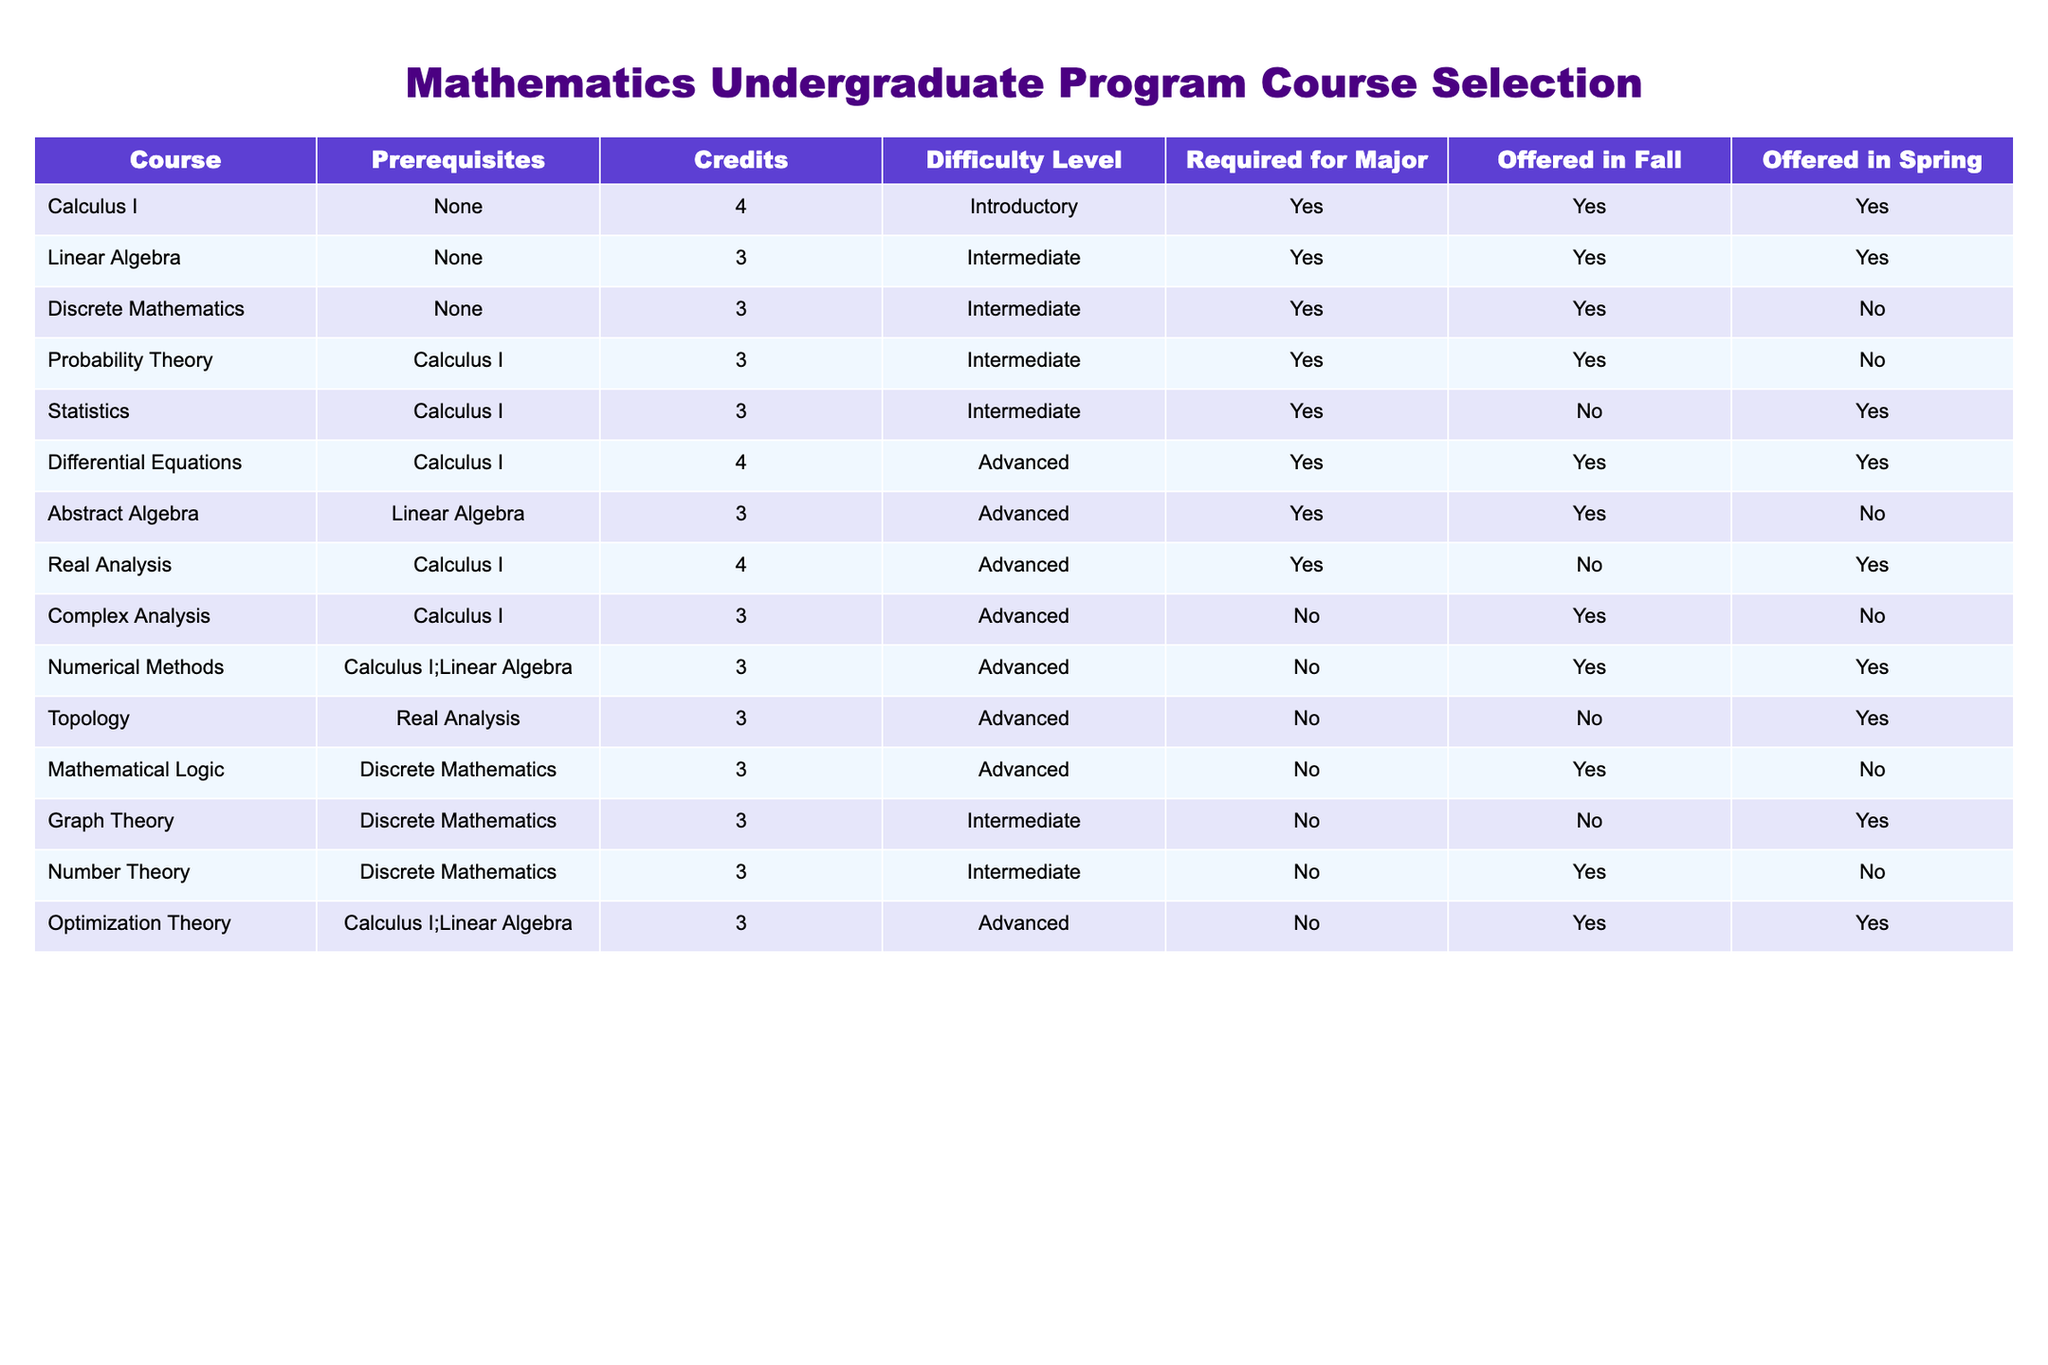What is the total number of credits required for Differential Equations? The table indicates that Differential Equations has 4 credits. Therefore, the total number of credits required for this course is simply the value found in the 'Credits' column for this course.
Answer: 4 Is Real Analysis offered in the Spring semester? According to the 'Offered in Spring' column, Real Analysis is marked as 'No'. This indicates that the course is not available in the Spring semester.
Answer: No How many courses have prerequisites? By examining the 'Prerequisites' column, we can identify which courses have prerequisites listed. These courses are Probability Theory, Statistics, Differential Equations, Abstract Algebra, Real Analysis, Numerical Methods, Optimization Theory, which totals to 6 courses with prerequisites.
Answer: 6 What is the average number of credits for courses that are required for the major? To find this, we first identify the courses that are required for the major, which are all courses except Complex Analysis, Topology, Mathematical Logic, Graph Theory, and Number Theory. The required courses are Calculus I (4), Linear Algebra (3), Discrete Mathematics (3), Probability Theory (3), Statistics (3), Differential Equations (4), Abstract Algebra (3), Real Analysis (4), Numerical Methods (3), and Optimization Theory (3). The total number of credits for these courses sums up to 34 credits (4 + 3 + 3 + 3 + 3 + 4 + 3 + 4 + 3 + 3 = 34). There are 10 courses, so the average number of credits is 34 / 10 = 3.4.
Answer: 3.4 How many Advanced level courses are offered in Fall? Looking at the table, we see which courses are categorized as Advanced and offered in Fall. The Advanced courses are Differential Equations, Abstract Algebra, Real Analysis, Complex Analysis, Numerical Methods, Topology, and Optimization Theory. Among these, II, III, and VI are offered in Fall as indicated by 'Yes' in the 'Offered in Fall' column. Thus, there are 5 Advanced level courses offered in Fall.
Answer: 5 Is there a course that requires both Calculus I and Linear Algebra as prerequisites? The table indicates that the only course requiring both Calculus I and Linear Algebra as prerequisites is Numerical Methods. Therefore, the answer must be derived by checking the 'Prerequisites' column for this specific pairing. Since it is found in the dataset, the answer is yes.
Answer: Yes Which courses are offered in Spring and have an Intermediate difficulty level? From the table, we check the 'Offered in Spring' column and the 'Difficulty Level' column. The Intermediate level courses are Linear Algebra, Probability Theory, Statistics, and Graph Theory. From these, Linear Algebra, Statistics, and Graph Theory are offered in Spring. Thus, three courses meet these criteria.
Answer: 3 